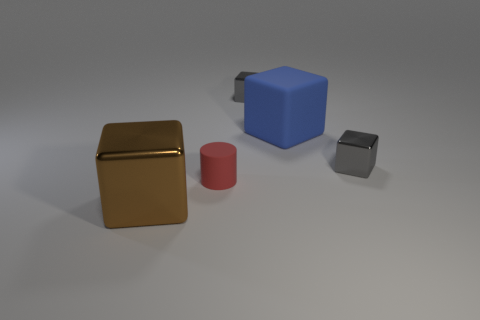There is a big object right of the tiny red cylinder; what color is it?
Your response must be concise. Blue. Is there another small matte thing that has the same shape as the blue thing?
Provide a succinct answer. No. What is the brown object made of?
Provide a succinct answer. Metal. What is the size of the metal cube that is in front of the big blue rubber cube and behind the brown cube?
Provide a short and direct response. Small. How many gray blocks are there?
Your response must be concise. 2. Is the number of red rubber objects less than the number of small gray blocks?
Give a very brief answer. Yes. There is a brown object that is the same size as the blue matte thing; what is it made of?
Your answer should be very brief. Metal. What number of things are either tiny red rubber spheres or tiny metallic cubes?
Your answer should be very brief. 2. What number of things are in front of the big blue matte cube and right of the small red rubber thing?
Provide a succinct answer. 1. Are there fewer blue rubber things that are on the left side of the tiny red matte thing than tiny green metallic cylinders?
Keep it short and to the point. No. 